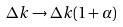Convert formula to latex. <formula><loc_0><loc_0><loc_500><loc_500>\Delta k \rightarrow \Delta k ( 1 + \alpha )</formula> 